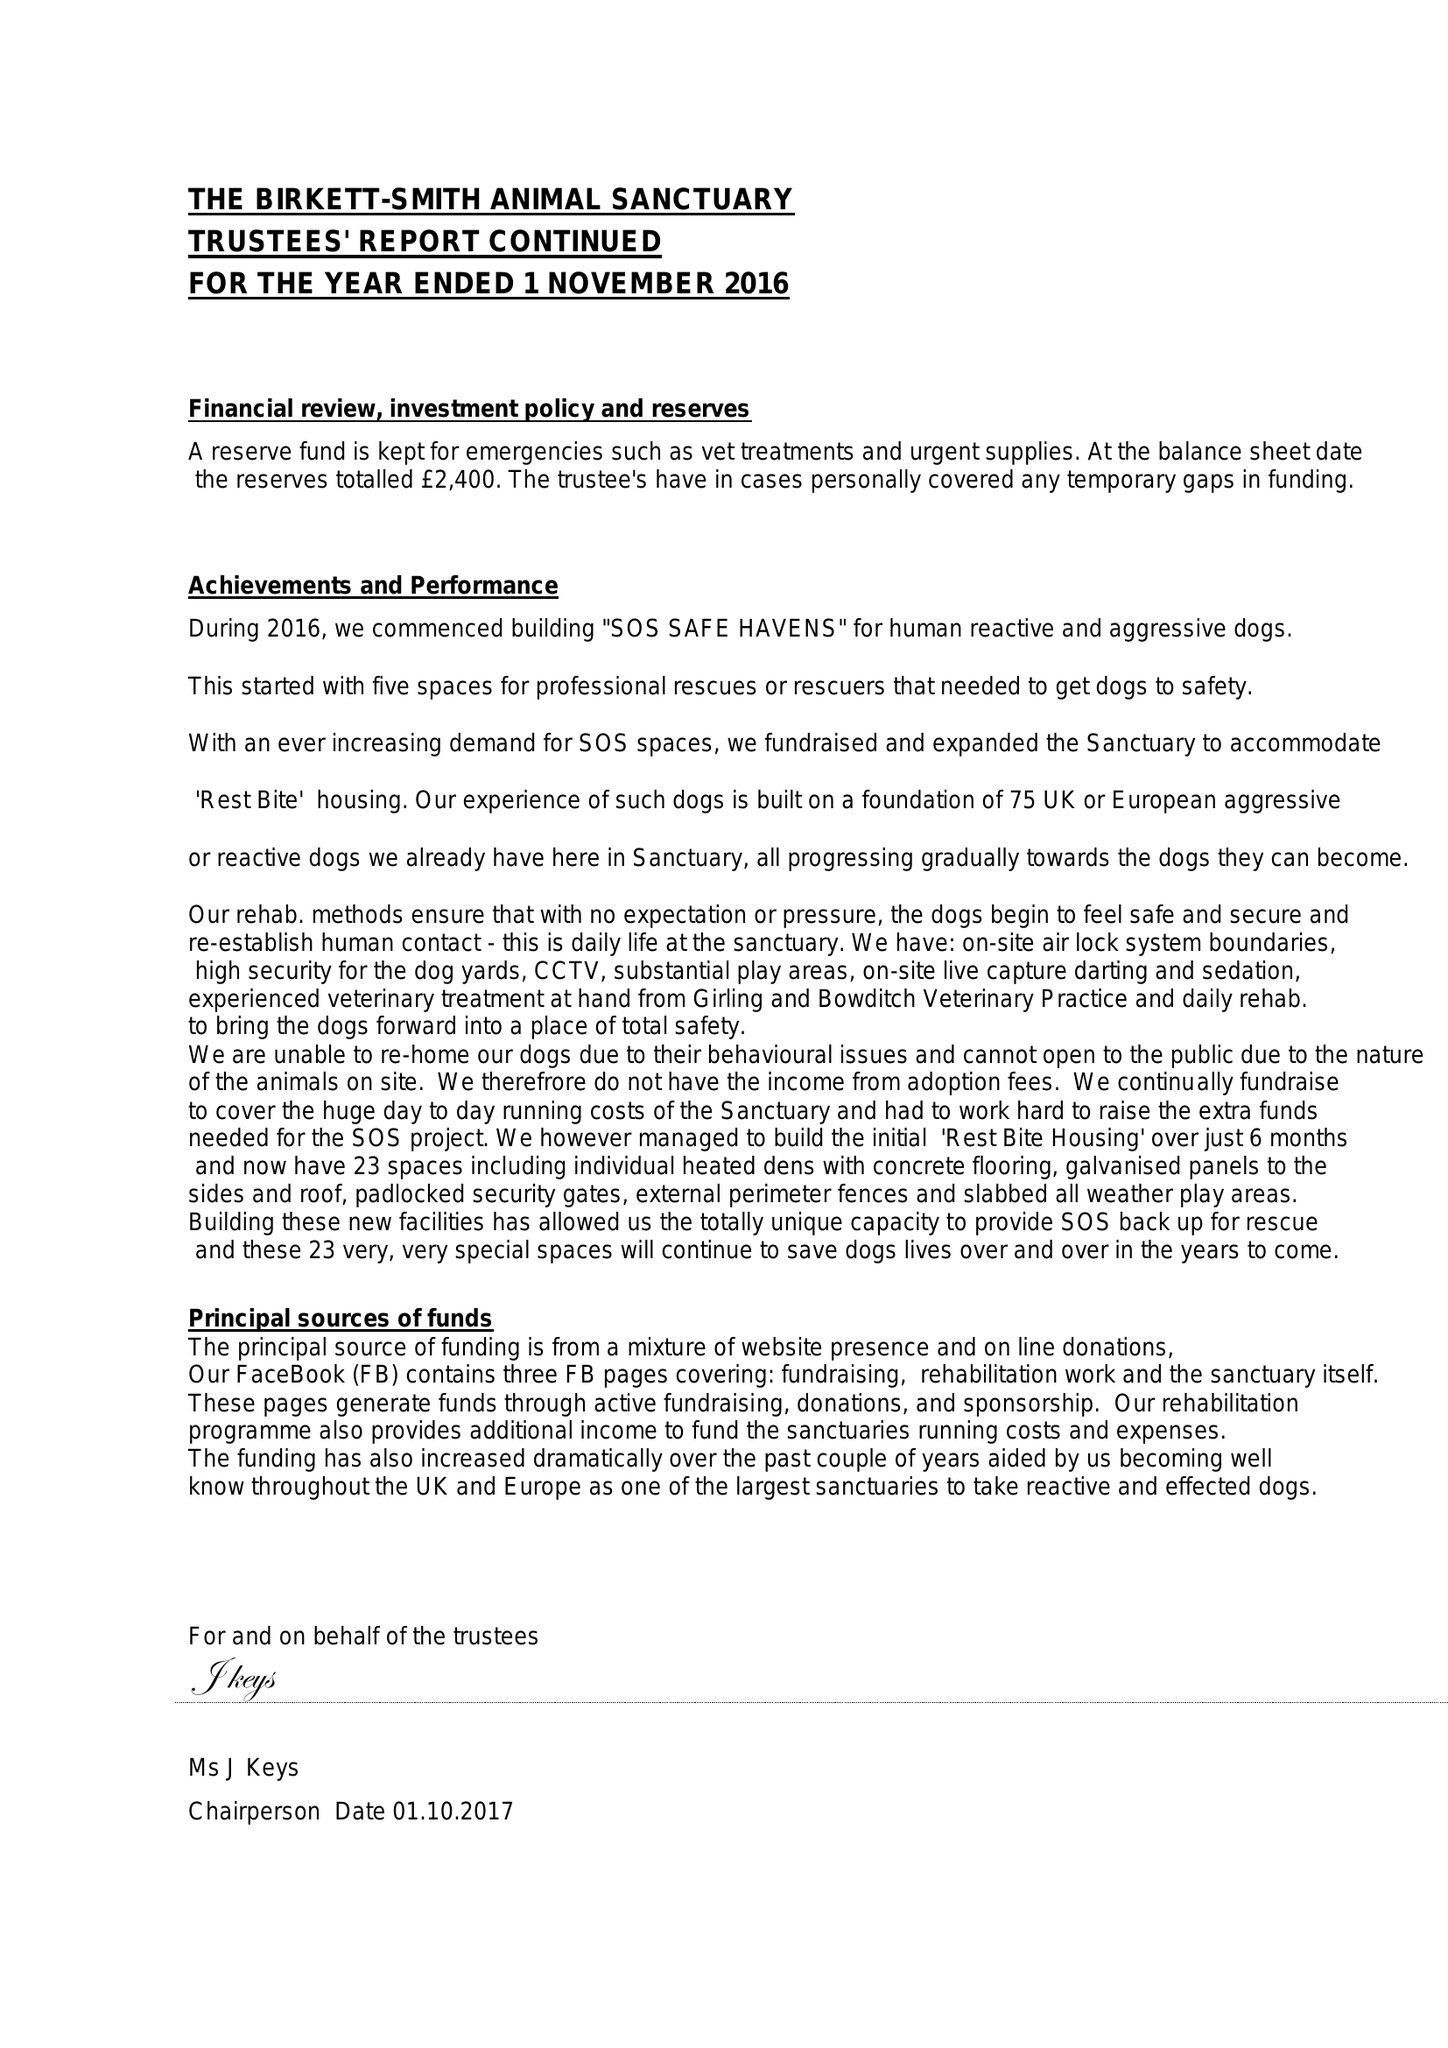What is the value for the income_annually_in_british_pounds?
Answer the question using a single word or phrase. 102844.00 